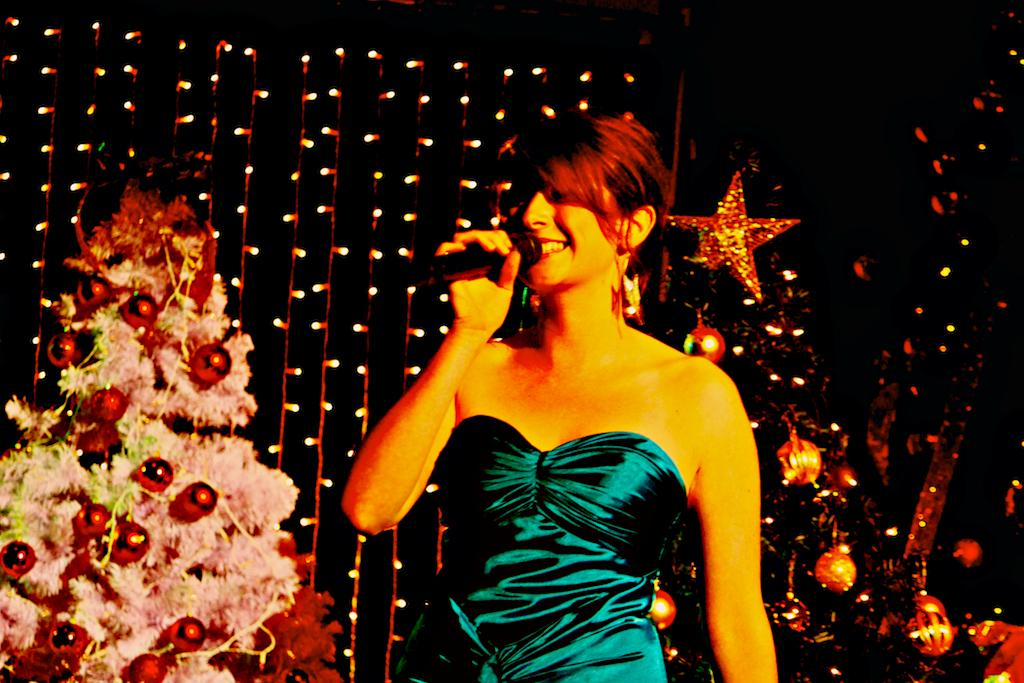What is the lady in the image doing? The lady is standing in the center of the image and holding a mic in her hand. What can be seen in the background of the image? There are Christmas trees and lights in the background of the image. Where is the cactus located in the image? There is no cactus present in the image. What type of statement is the lady making in the image? The image does not provide any information about a statement being made by the lady. 